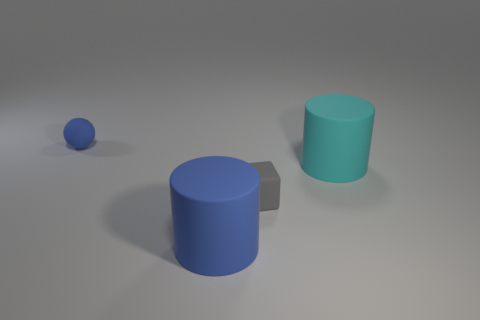What is the material of the small block?
Your answer should be very brief. Rubber. Is the number of blue cylinders in front of the cyan thing greater than the number of yellow metal things?
Keep it short and to the point. Yes. There is a big cylinder that is to the right of the matte cylinder that is to the left of the gray thing; how many small matte spheres are in front of it?
Offer a very short reply. 0. What color is the tiny sphere?
Give a very brief answer. Blue. Is the number of large cylinders that are behind the gray object greater than the number of small rubber objects in front of the cyan matte cylinder?
Offer a terse response. No. There is a big cylinder that is on the left side of the gray thing; what color is it?
Provide a succinct answer. Blue. Do the blue rubber thing behind the cyan thing and the gray rubber object that is in front of the small sphere have the same size?
Provide a short and direct response. Yes. What number of objects are either rubber things or tiny brown shiny blocks?
Your answer should be compact. 4. There is a cylinder that is right of the small rubber thing that is right of the blue cylinder; what is its material?
Offer a terse response. Rubber. How many big cyan things have the same shape as the big blue object?
Your answer should be compact. 1. 